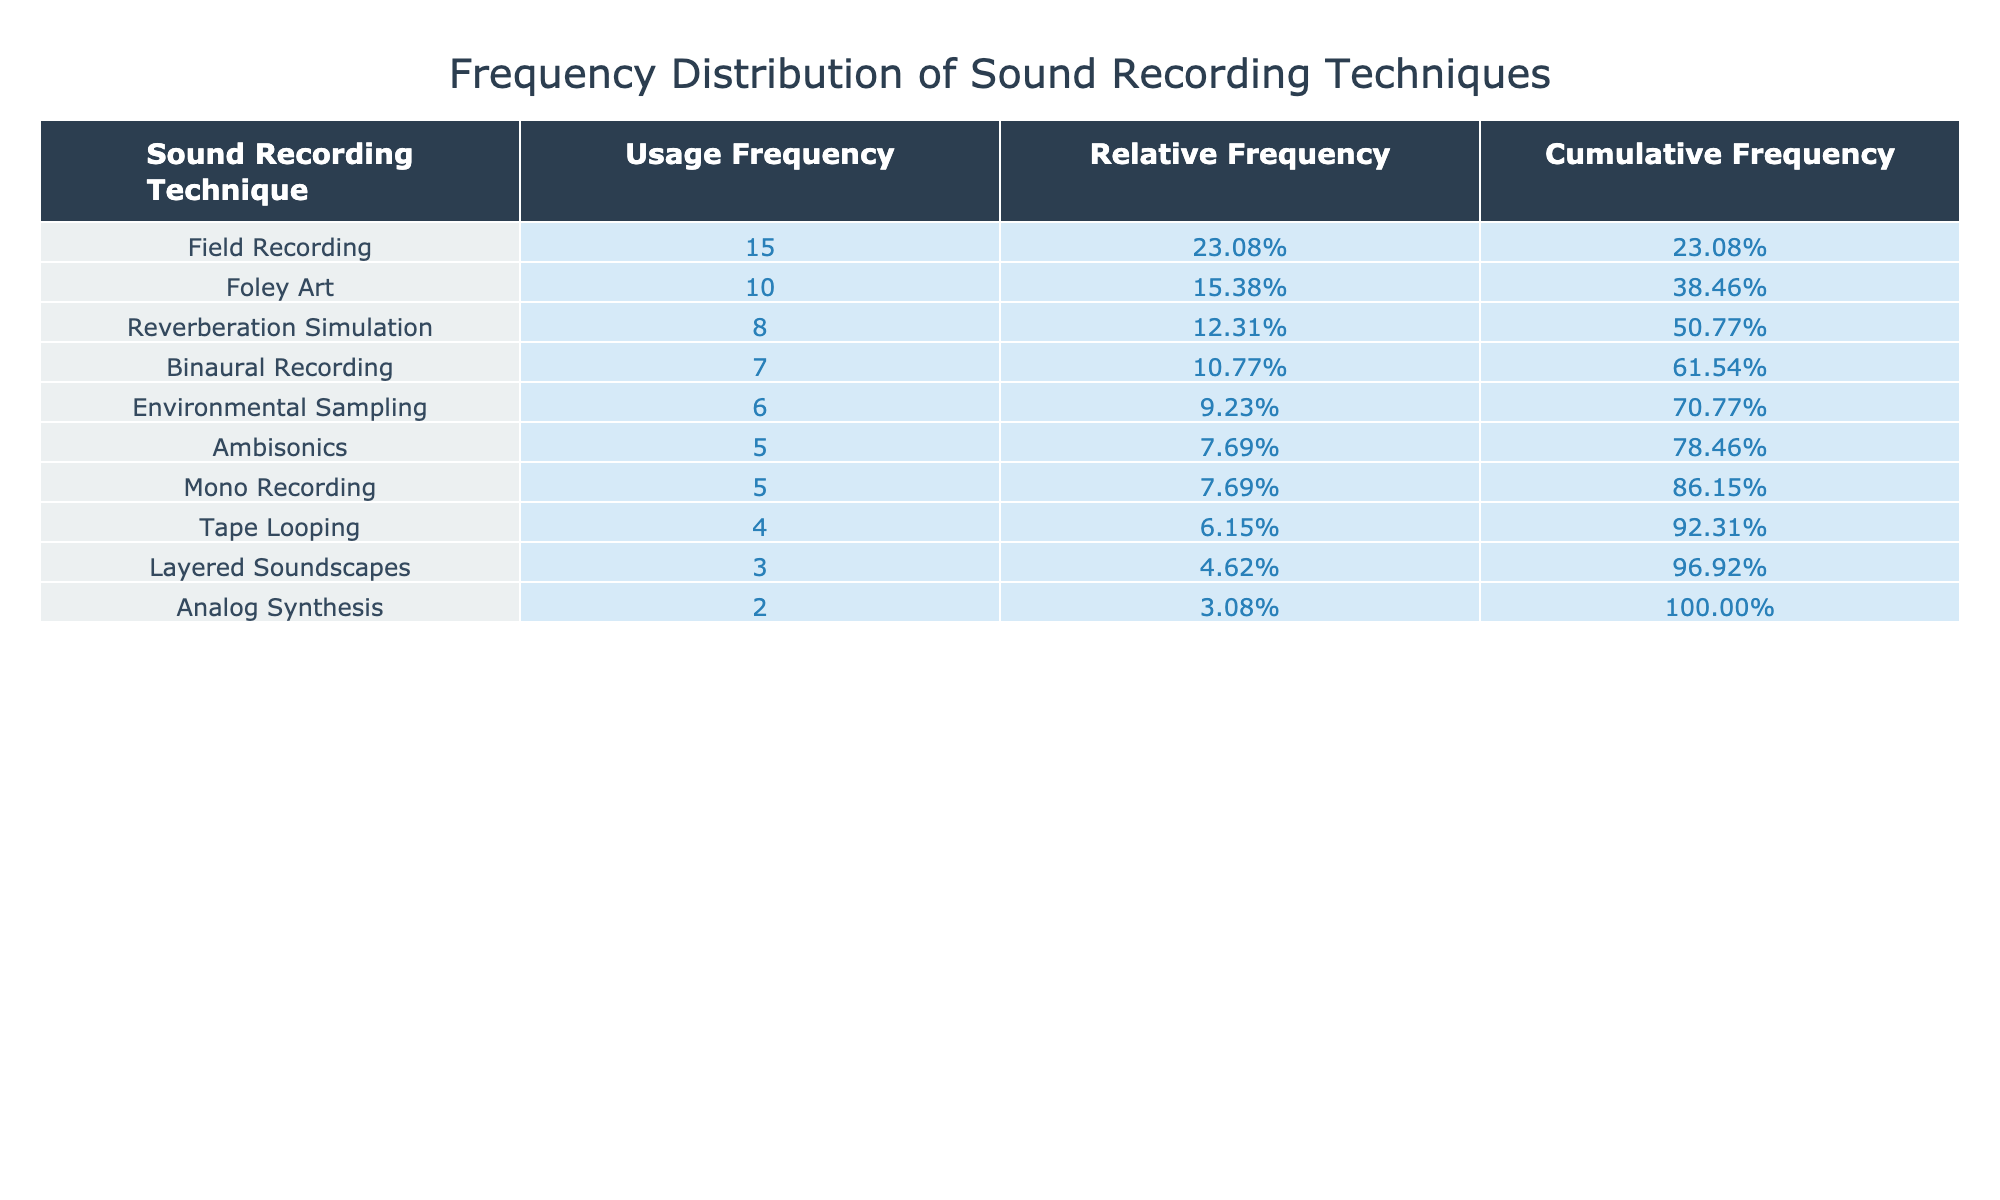What is the most frequently used sound recording technique? By looking at the Usage Frequency column, Field Recording has the highest value of 15, which indicates it is the most frequently used technique.
Answer: Field Recording What is the usage frequency of Foley Art? The Usage Frequency for Foley Art can be directly found in the table, which shows a value of 10.
Answer: 10 Is Binaural Recording used more frequently than Tape Looping? Yes, Binaural Recording has a usage frequency of 7, while Tape Looping has a lower frequency of 4.
Answer: Yes What is the cumulative frequency of the top three sound recording techniques? The top three techniques are Field Recording (15), Foley Art (10), and Reverberation Simulation (8). To find the cumulative frequency, add these values: 15 + 10 + 8 = 33.
Answer: 33 What percentage of the total usage frequency does Environmental Sampling account for? The total usage frequency is the sum of all frequencies: 15 + 10 + 8 + 5 + 7 + 6 + 4 + 3 + 2 + 5 = 60. Environmental Sampling has a frequency of 6. To find the percentage, calculate (6/60) * 100 = 10%.
Answer: 10% Is Layered Soundscapes more frequently used than Mono Recording? No, Layered Soundscapes has a usage frequency of 3, while Mono Recording is used more frequently at a usage frequency of 5.
Answer: No What is the difference in usage frequency between the least and most used techniques? The least used technique is Analog Synthesis with a value of 2, and the most used is Field Recording with a value of 15. The difference is 15 - 2 = 13.
Answer: 13 What is the average usage frequency across all techniques? To find the average, sum all the usage frequencies: 15 + 10 + 8 + 5 + 7 + 6 + 4 + 3 + 2 + 5 = 60. There are 10 techniques, so the average is 60/10 = 6.
Answer: 6 Which technique has a cumulative frequency closest to 50% of the total usage frequencies? First, the total usage frequency is 60, so 50% is 30. The cumulative frequencies need to be considered: Field Recording (15), Foley Art (25), and Reverberation Simulation (33) puts it above 30. Foley Art has a cumulative frequency of 25, which is the closest without exceeding.
Answer: Foley Art 